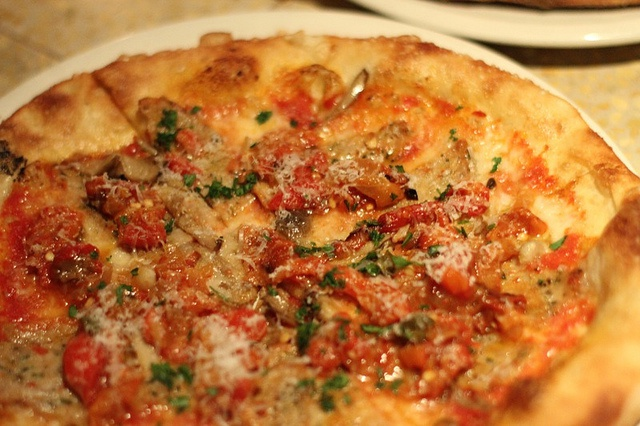Describe the objects in this image and their specific colors. I can see a pizza in brown, olive, orange, and red tones in this image. 